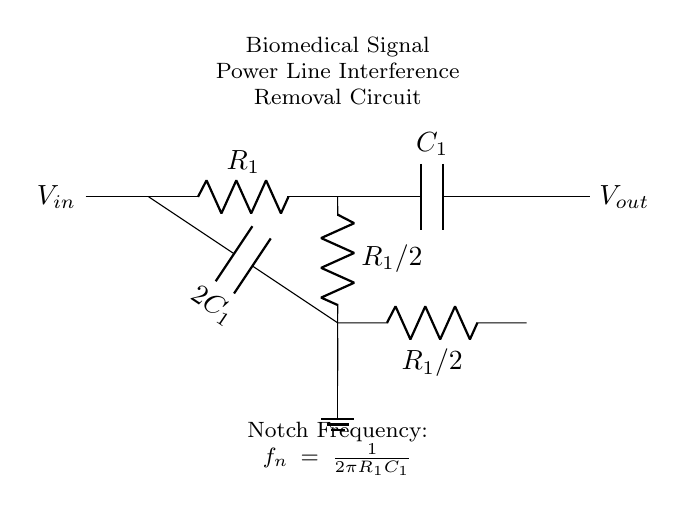What is the name of this circuit? This circuit is called a Twin-T Notch Filter, which is designed to remove power line interference from sensitive biomedical measurements. The label in the circuit diagram explicitly states this.
Answer: Twin-T Notch Filter What does V-in represent? V-in represents the input voltage to the circuit, as indicated by the label on the left side of the circuit diagram. It is the voltage signal that will have power line interference removed.
Answer: Input voltage What is the value of C1 in the circuit? The value of C1 is represented as the capacitance directly before the node in the circuit. It is labeled as C1 in the diagram. The specific numerical value is typically provided in supporting documents but is not shown here.
Answer: C1 What is the formula for the notch frequency? The notch frequency is given by the formula f_n = 1/(2πR_1C_1). This is noted in the circuit diagram itself, providing a direct calculation for determining the frequency at which interference is minimized.
Answer: f_n = 1/(2πR_1C_1) How many resistors are in the circuit? There are three resistors shown in the circuit. Each resistor is labeled with its value, and they are connected in various ways to achieve the desired filtering effect. Counting the labeled resistors provides the total.
Answer: Three What does the "2C1" label indicate? The label "2C1" indicates that the capacitance of that particular capacitor is twice the value of C1. This is shown in the circuit, and it reflects how this specific capacitance is used in the filter design.
Answer: Two times C1 What is the role of ground in this circuit? The ground serves as a reference point for voltage measurements and stabilizes the circuit by providing a common return path for current. It is essential for ensuring proper function and safety in the circuit. The diagram shows how one of the components connects to ground.
Answer: Reference point 